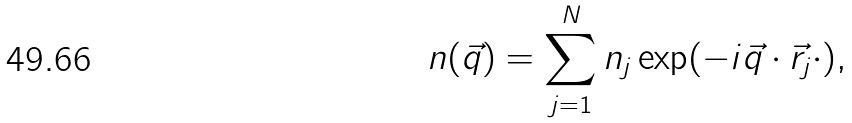<formula> <loc_0><loc_0><loc_500><loc_500>n ( \vec { q } ) = \sum _ { j = 1 } ^ { N } n _ { j } \exp ( - i \vec { q } \cdot \vec { r } _ { j } \cdot ) ,</formula> 